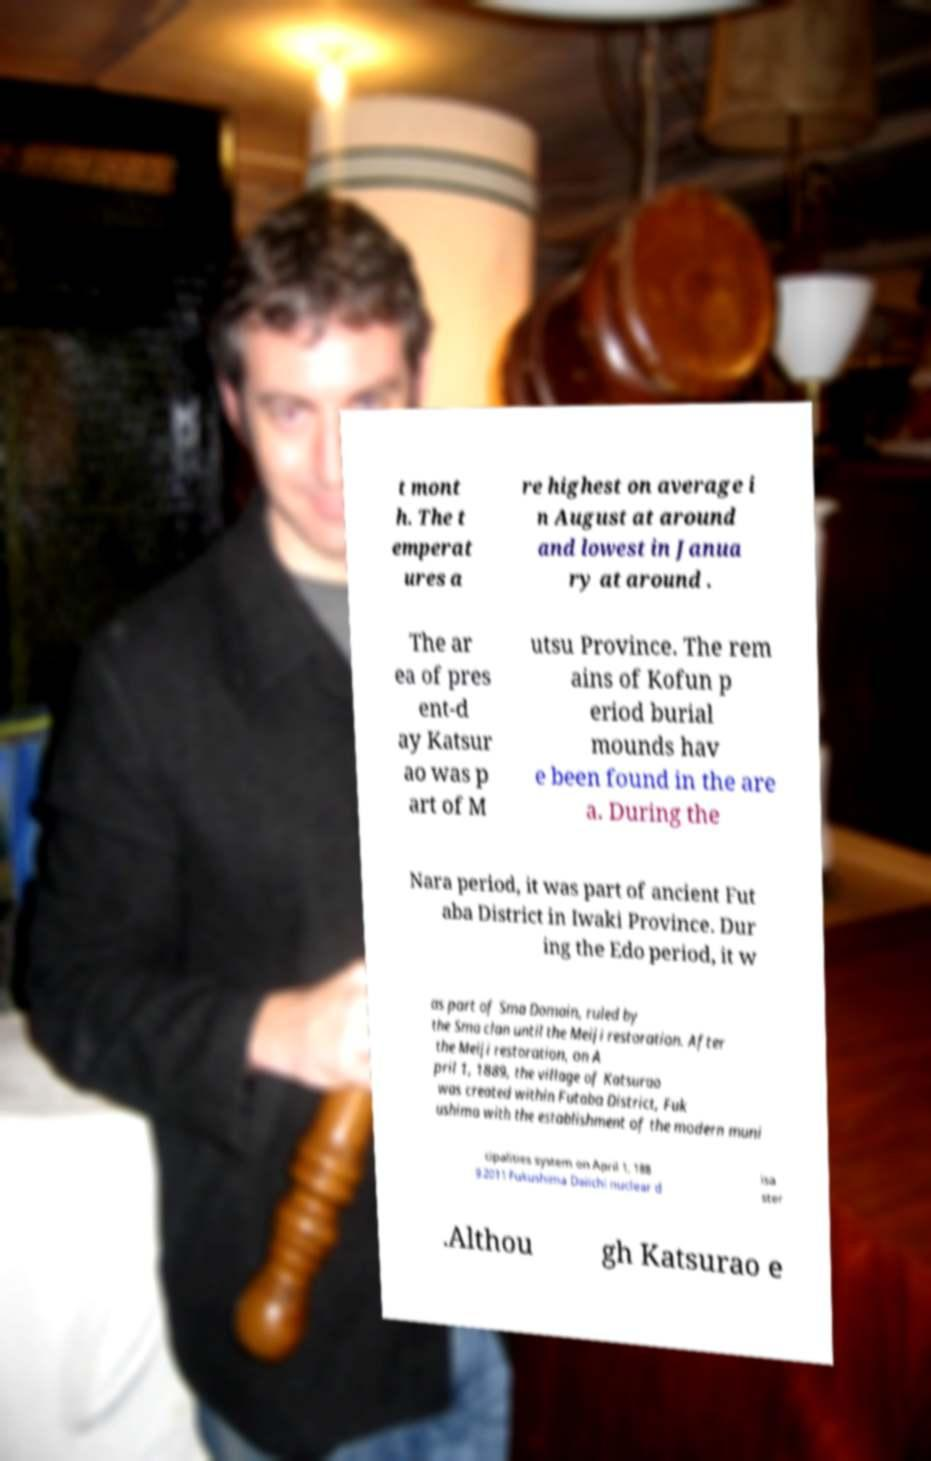Can you read and provide the text displayed in the image?This photo seems to have some interesting text. Can you extract and type it out for me? t mont h. The t emperat ures a re highest on average i n August at around and lowest in Janua ry at around . The ar ea of pres ent-d ay Katsur ao was p art of M utsu Province. The rem ains of Kofun p eriod burial mounds hav e been found in the are a. During the Nara period, it was part of ancient Fut aba District in Iwaki Province. Dur ing the Edo period, it w as part of Sma Domain, ruled by the Sma clan until the Meiji restoration. After the Meiji restoration, on A pril 1, 1889, the village of Katsurao was created within Futaba District, Fuk ushima with the establishment of the modern muni cipalities system on April 1, 188 9.2011 Fukushima Daiichi nuclear d isa ster .Althou gh Katsurao e 